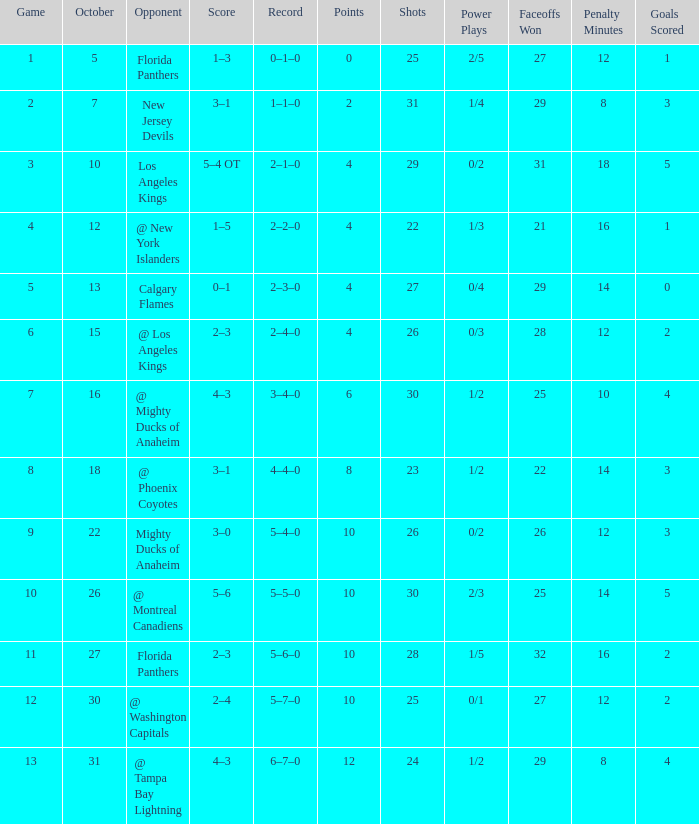What team has a score of 11 5–6–0. 